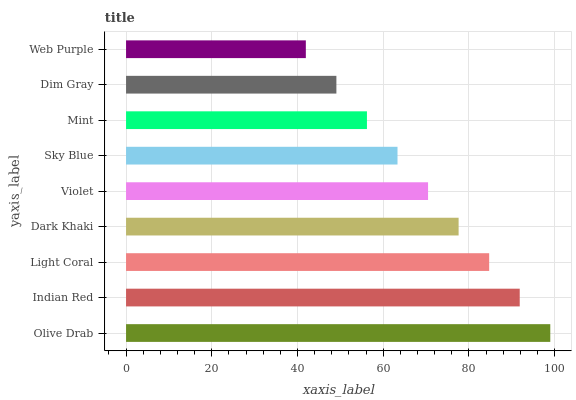Is Web Purple the minimum?
Answer yes or no. Yes. Is Olive Drab the maximum?
Answer yes or no. Yes. Is Indian Red the minimum?
Answer yes or no. No. Is Indian Red the maximum?
Answer yes or no. No. Is Olive Drab greater than Indian Red?
Answer yes or no. Yes. Is Indian Red less than Olive Drab?
Answer yes or no. Yes. Is Indian Red greater than Olive Drab?
Answer yes or no. No. Is Olive Drab less than Indian Red?
Answer yes or no. No. Is Violet the high median?
Answer yes or no. Yes. Is Violet the low median?
Answer yes or no. Yes. Is Mint the high median?
Answer yes or no. No. Is Sky Blue the low median?
Answer yes or no. No. 